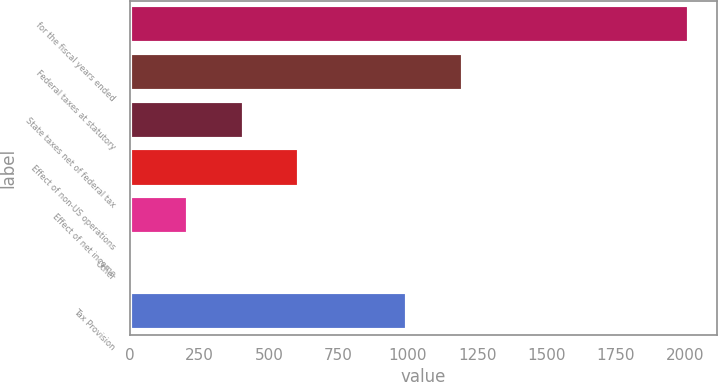Convert chart to OTSL. <chart><loc_0><loc_0><loc_500><loc_500><bar_chart><fcel>for the fiscal years ended<fcel>Federal taxes at statutory<fcel>State taxes net of federal tax<fcel>Effect of non-US operations<fcel>Effect of net income<fcel>Other<fcel>Tax Provision<nl><fcel>2014<fcel>1198.5<fcel>409.2<fcel>609.8<fcel>208.6<fcel>8<fcel>997.9<nl></chart> 